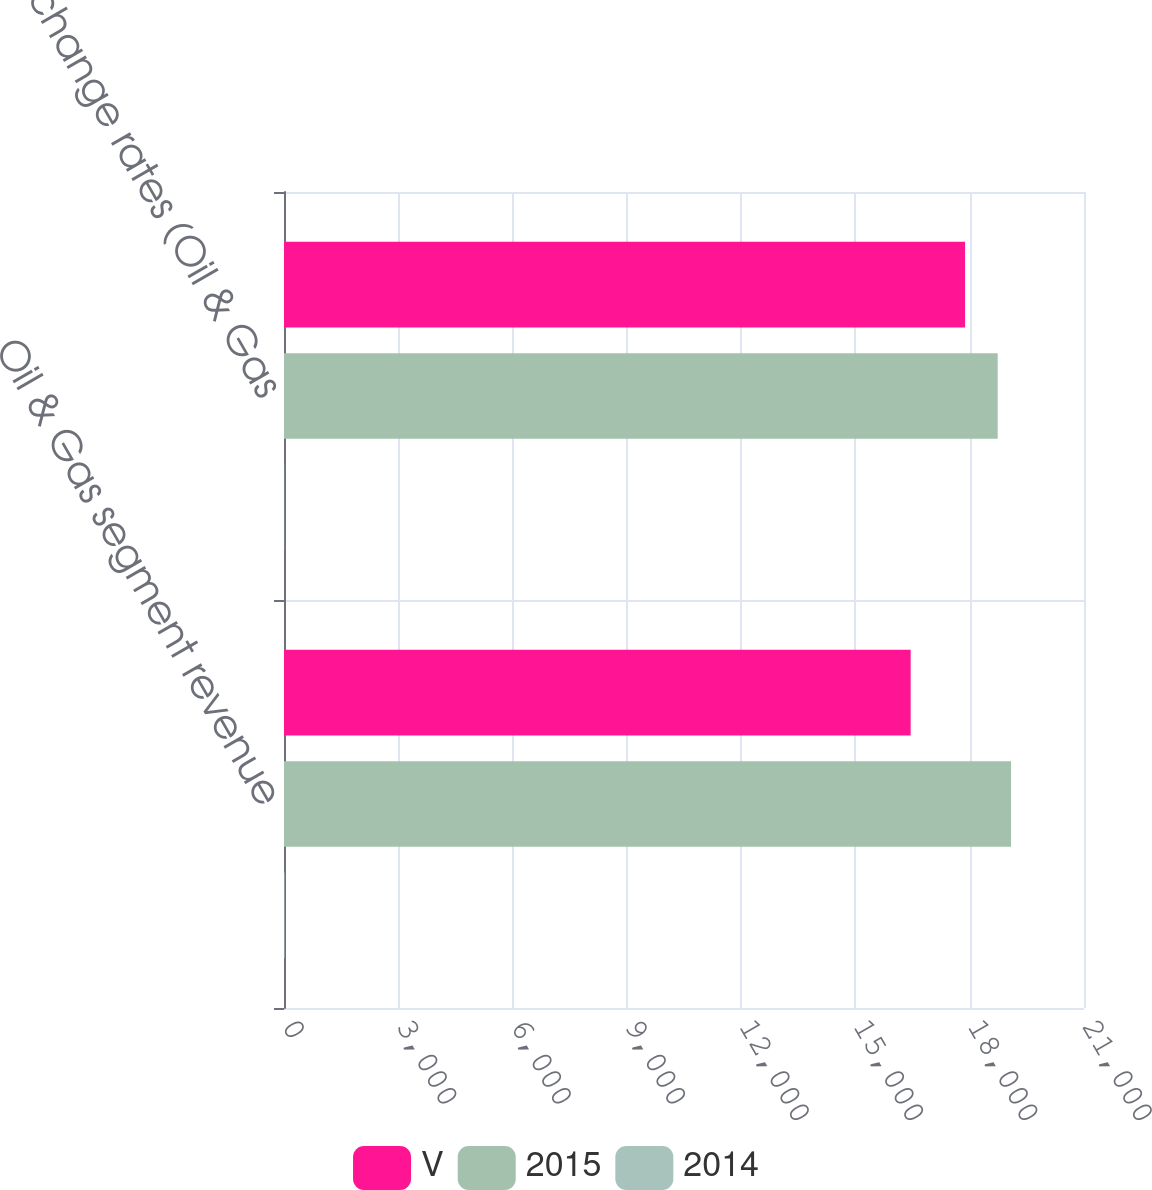Convert chart to OTSL. <chart><loc_0><loc_0><loc_500><loc_500><stacked_bar_chart><ecel><fcel>Oil & Gas segment revenue<fcel>exchange rates (Oil & Gas<nl><fcel>V<fcel>16450<fcel>17878<nl><fcel>2015<fcel>19085<fcel>18735<nl><fcel>2014<fcel>14<fcel>5<nl></chart> 